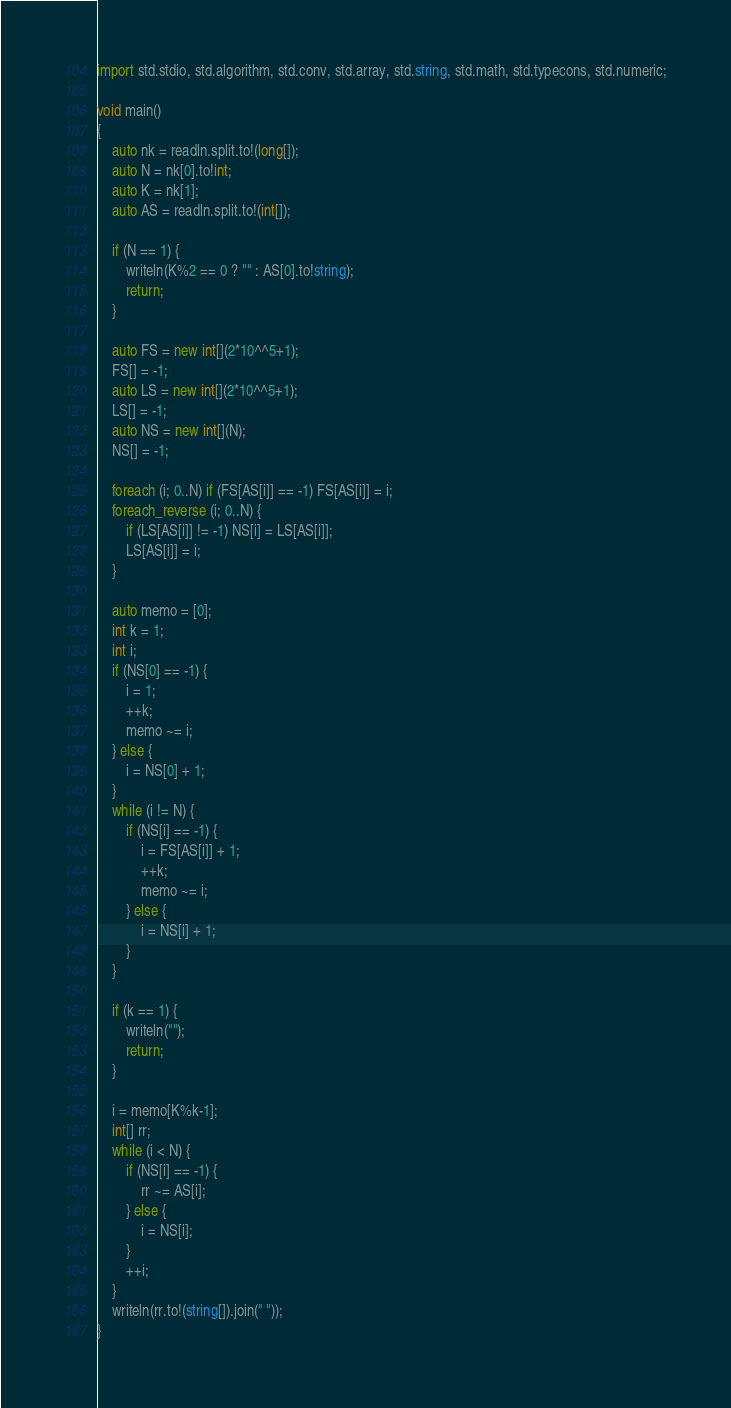<code> <loc_0><loc_0><loc_500><loc_500><_D_>import std.stdio, std.algorithm, std.conv, std.array, std.string, std.math, std.typecons, std.numeric;

void main()
{
    auto nk = readln.split.to!(long[]);
    auto N = nk[0].to!int;
    auto K = nk[1];
    auto AS = readln.split.to!(int[]);

    if (N == 1) {
        writeln(K%2 == 0 ? "" : AS[0].to!string);
        return;
    }

    auto FS = new int[](2*10^^5+1);
    FS[] = -1;
    auto LS = new int[](2*10^^5+1);
    LS[] = -1;
    auto NS = new int[](N);
    NS[] = -1;

    foreach (i; 0..N) if (FS[AS[i]] == -1) FS[AS[i]] = i;
    foreach_reverse (i; 0..N) {
        if (LS[AS[i]] != -1) NS[i] = LS[AS[i]];
        LS[AS[i]] = i;
    }

    auto memo = [0];
    int k = 1;
    int i;
    if (NS[0] == -1) {
        i = 1;
        ++k;
        memo ~= i;
    } else {
        i = NS[0] + 1;
    }
    while (i != N) {
        if (NS[i] == -1) {
            i = FS[AS[i]] + 1;
            ++k;
            memo ~= i;
        } else {
            i = NS[i] + 1;
        }
    }

    if (k == 1) {
        writeln("");
        return;
    }

    i = memo[K%k-1];
    int[] rr;
    while (i < N) {
        if (NS[i] == -1) {
            rr ~= AS[i];
        } else {
            i = NS[i];
        }
        ++i;
    }
    writeln(rr.to!(string[]).join(" "));
}</code> 